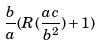Convert formula to latex. <formula><loc_0><loc_0><loc_500><loc_500>\frac { b } { a } ( R ( \frac { a c } { b ^ { 2 } } ) + 1 )</formula> 